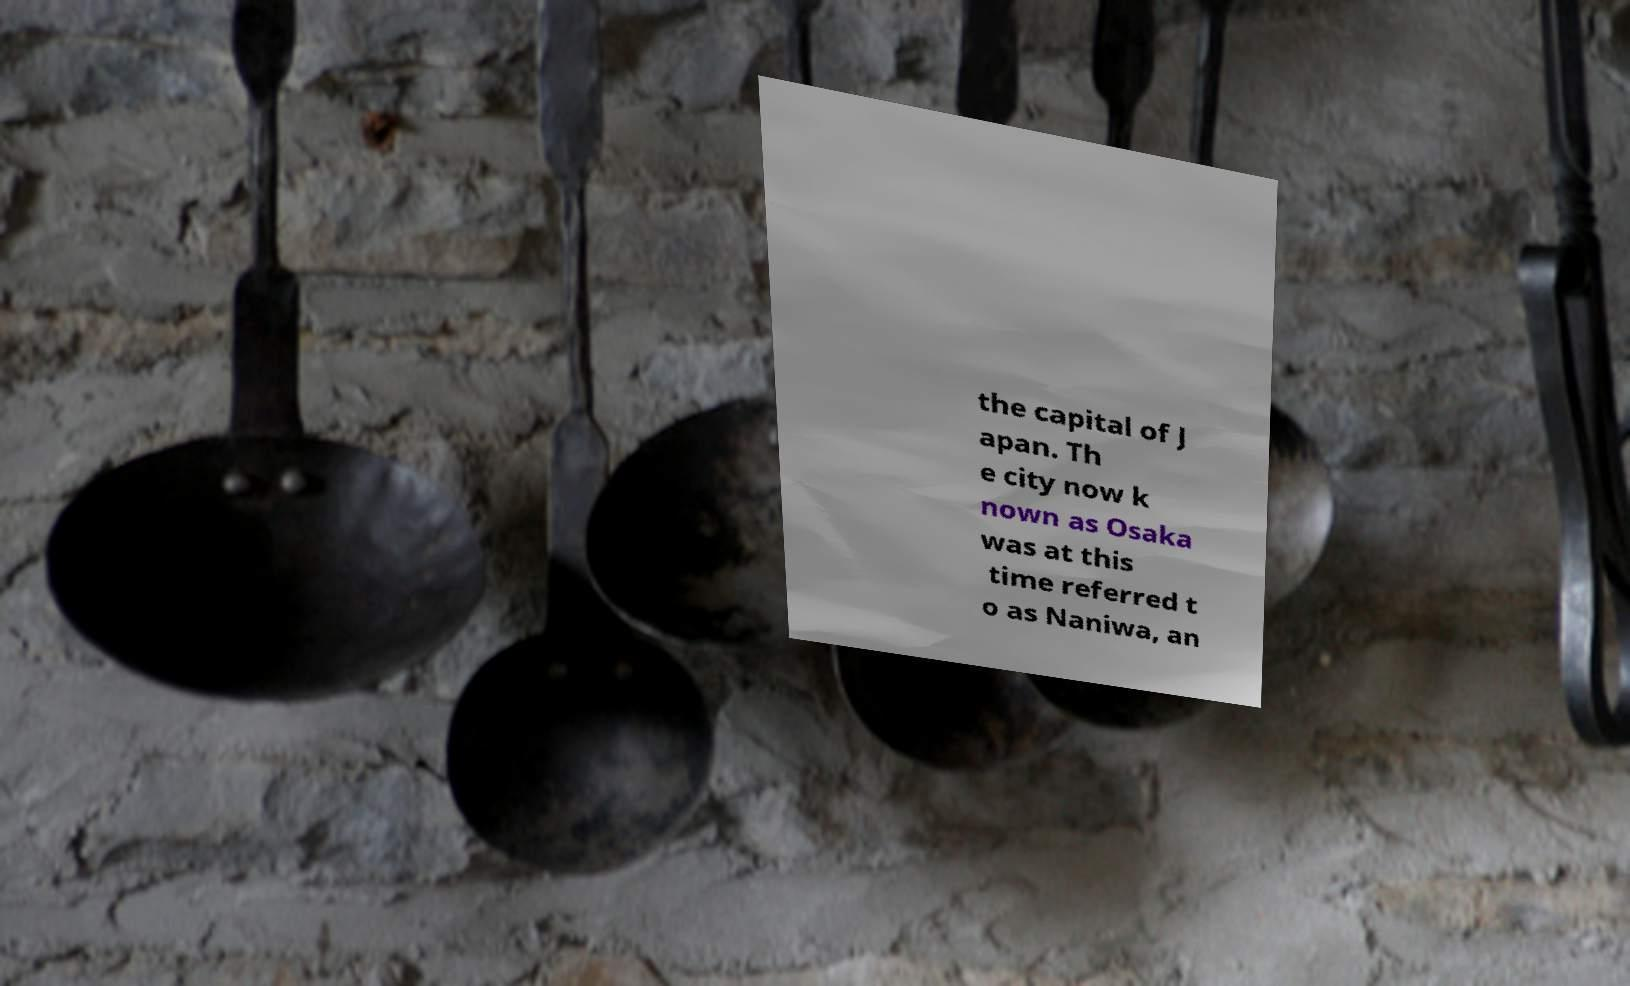I need the written content from this picture converted into text. Can you do that? the capital of J apan. Th e city now k nown as Osaka was at this time referred t o as Naniwa, an 